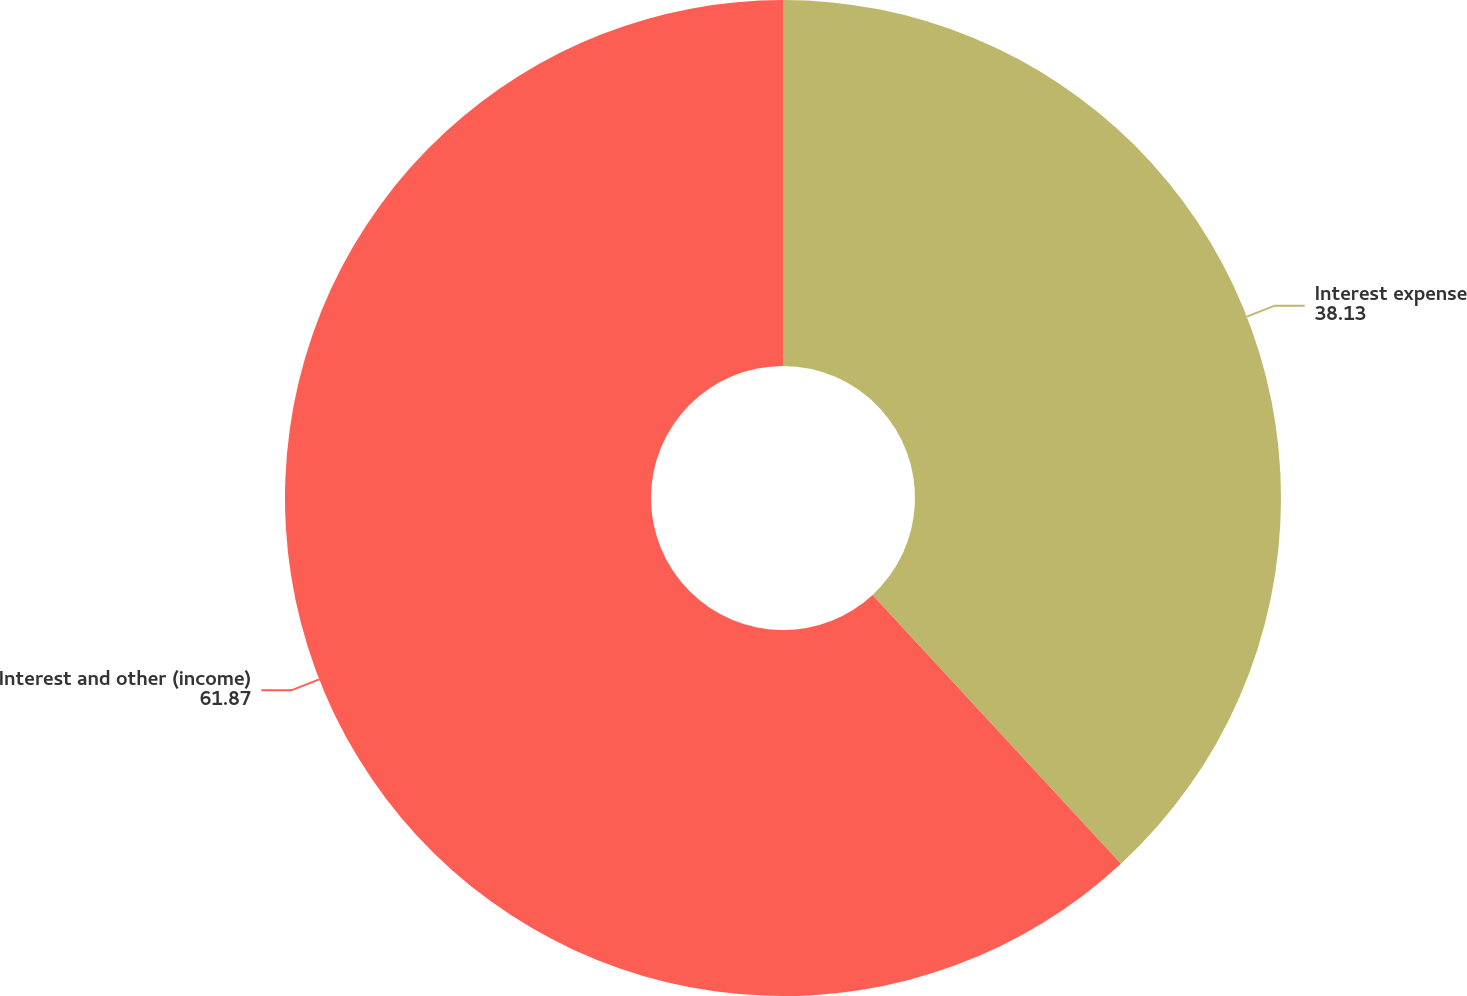Convert chart to OTSL. <chart><loc_0><loc_0><loc_500><loc_500><pie_chart><fcel>Interest expense<fcel>Interest and other (income)<nl><fcel>38.13%<fcel>61.87%<nl></chart> 